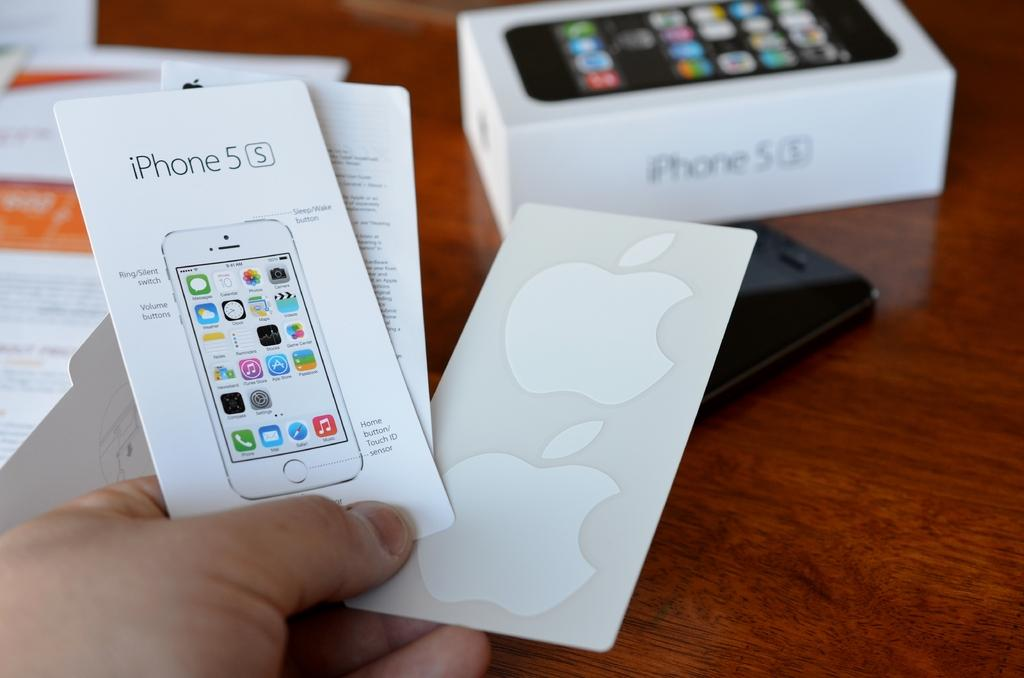Provide a one-sentence caption for the provided image. A hand is holding an iphone 5s booklet and Apple stickers with a box for the iphone 5s in the background. 